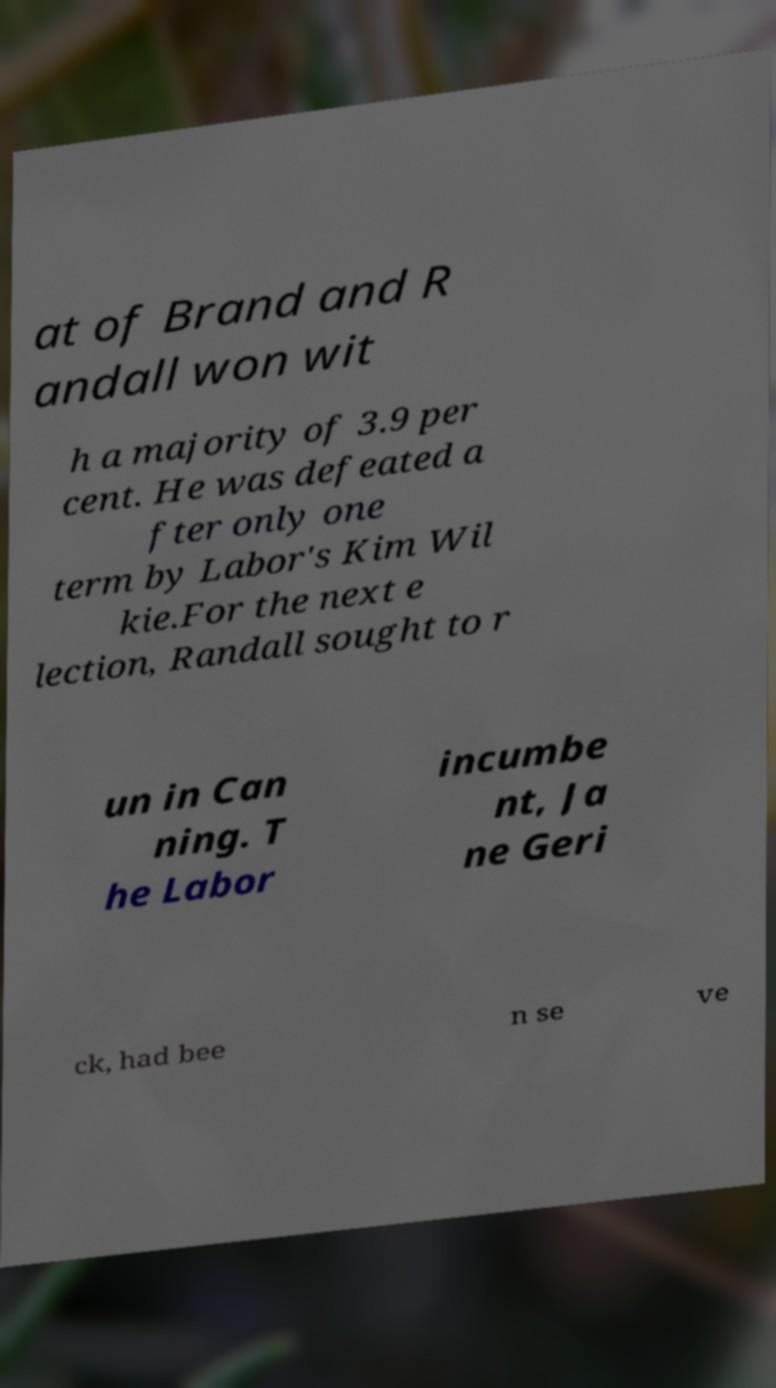Could you extract and type out the text from this image? at of Brand and R andall won wit h a majority of 3.9 per cent. He was defeated a fter only one term by Labor's Kim Wil kie.For the next e lection, Randall sought to r un in Can ning. T he Labor incumbe nt, Ja ne Geri ck, had bee n se ve 